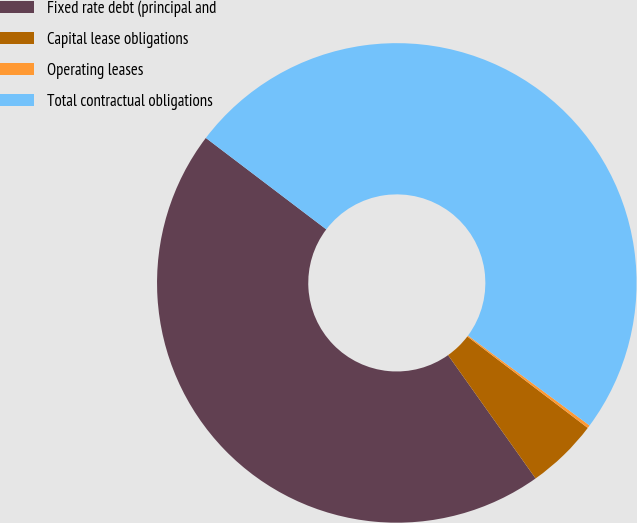Convert chart to OTSL. <chart><loc_0><loc_0><loc_500><loc_500><pie_chart><fcel>Fixed rate debt (principal and<fcel>Capital lease obligations<fcel>Operating leases<fcel>Total contractual obligations<nl><fcel>45.16%<fcel>4.84%<fcel>0.2%<fcel>49.8%<nl></chart> 